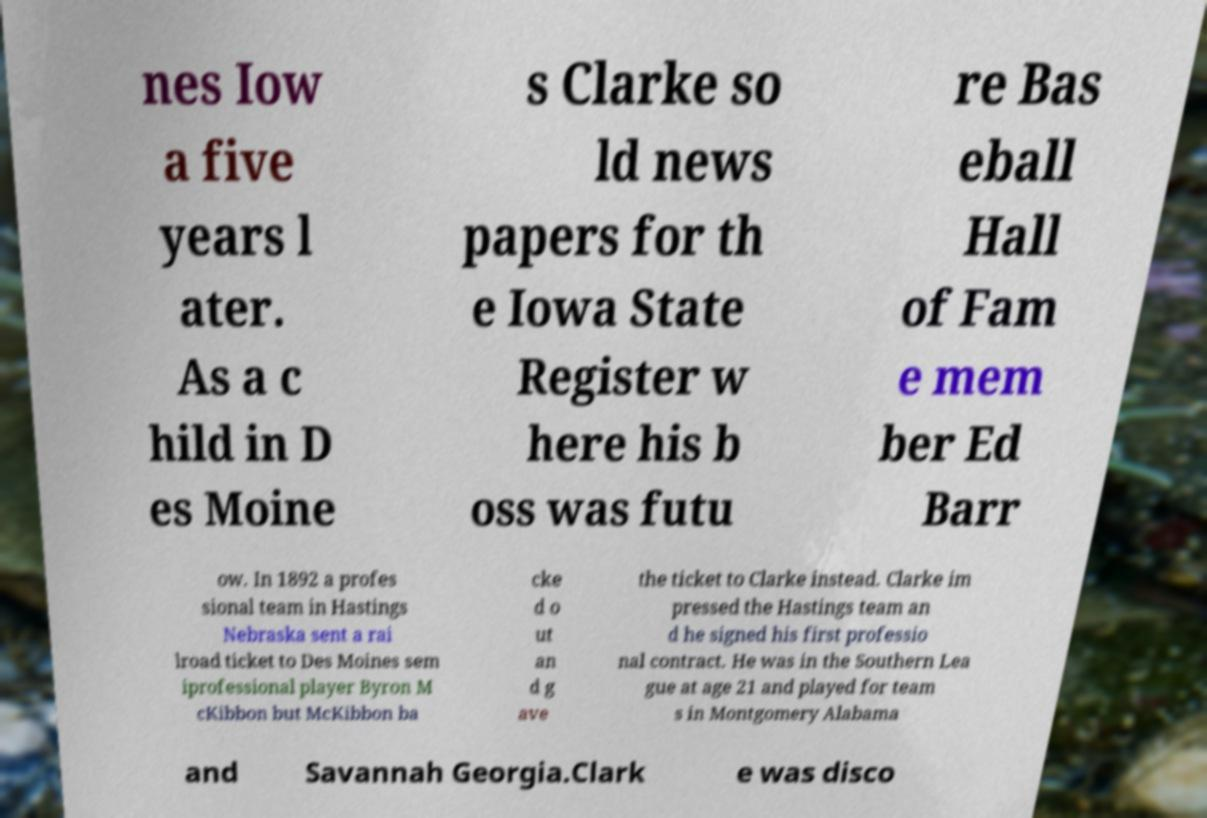For documentation purposes, I need the text within this image transcribed. Could you provide that? nes Iow a five years l ater. As a c hild in D es Moine s Clarke so ld news papers for th e Iowa State Register w here his b oss was futu re Bas eball Hall of Fam e mem ber Ed Barr ow. In 1892 a profes sional team in Hastings Nebraska sent a rai lroad ticket to Des Moines sem iprofessional player Byron M cKibbon but McKibbon ba cke d o ut an d g ave the ticket to Clarke instead. Clarke im pressed the Hastings team an d he signed his first professio nal contract. He was in the Southern Lea gue at age 21 and played for team s in Montgomery Alabama and Savannah Georgia.Clark e was disco 